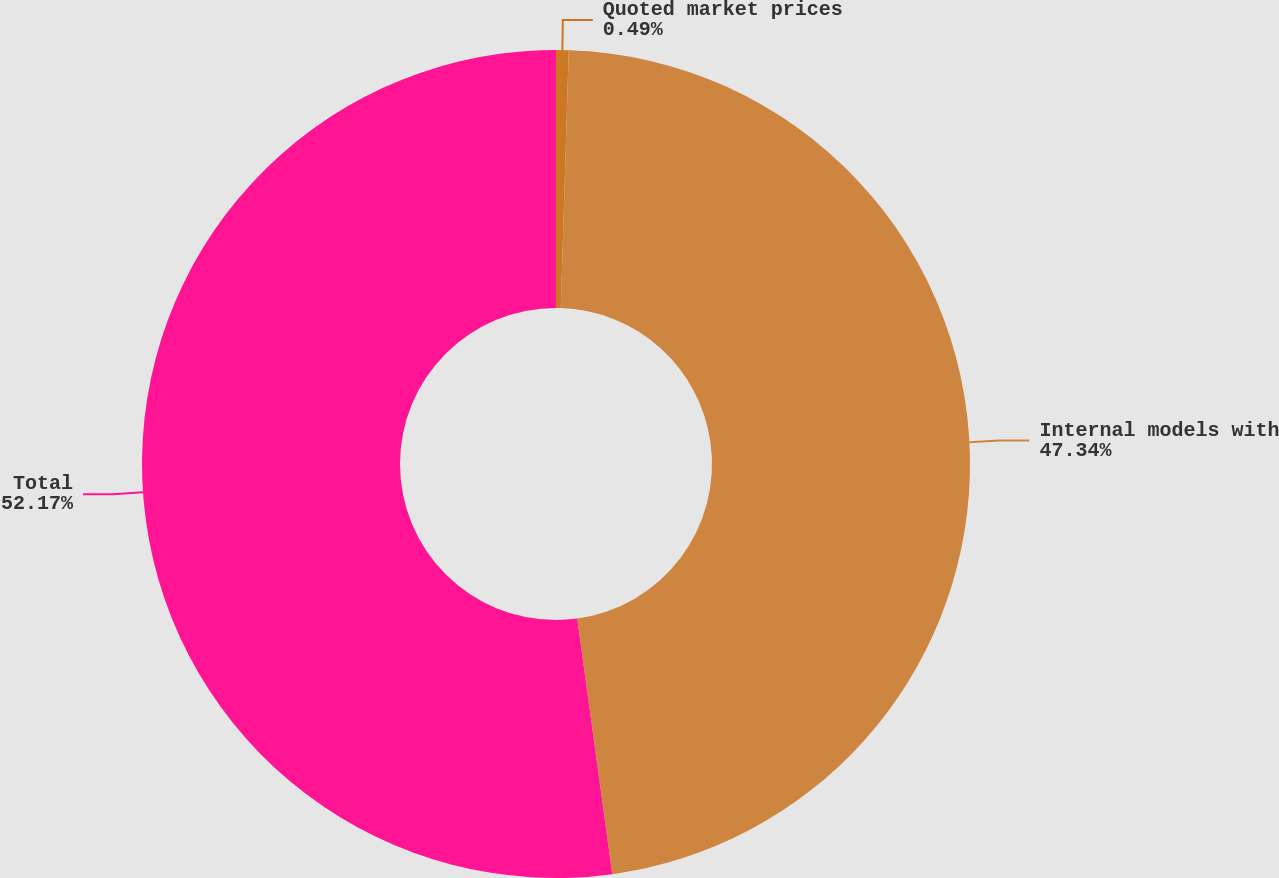Convert chart. <chart><loc_0><loc_0><loc_500><loc_500><pie_chart><fcel>Quoted market prices<fcel>Internal models with<fcel>Total<nl><fcel>0.49%<fcel>47.34%<fcel>52.17%<nl></chart> 